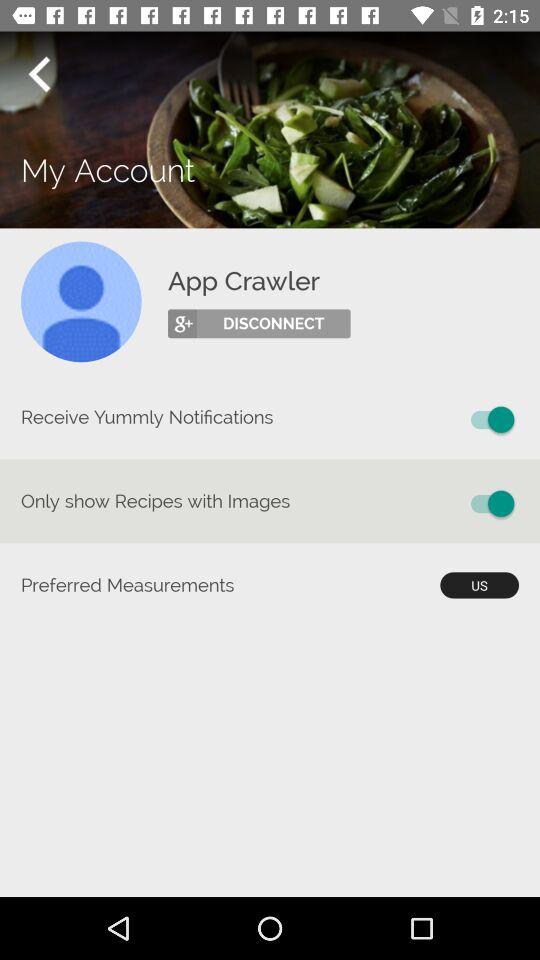What is the status of the "Only show Recipes with Images"? The status of the "Only show Recipes with Images" is "on". 